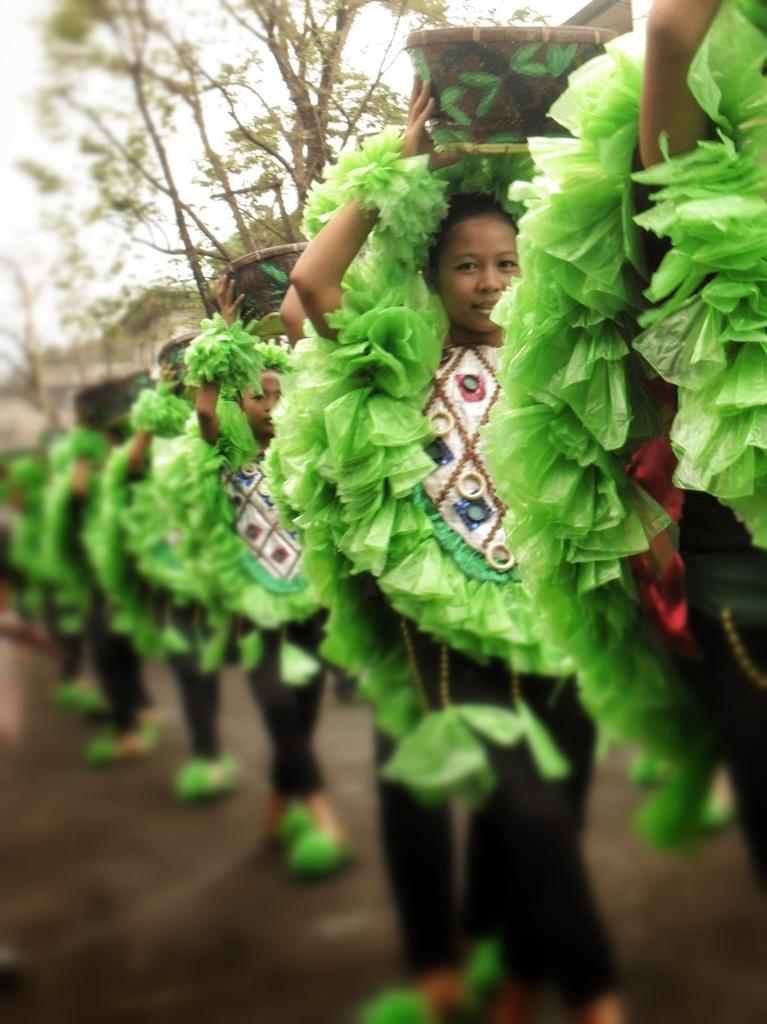Could you give a brief overview of what you see in this image? In this image we can see there are people standing and holding a basket and there are trees and the sky. 